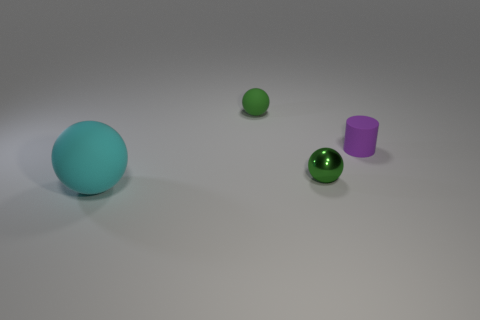Is the shape of the tiny green thing that is in front of the purple rubber object the same as the matte object that is in front of the purple rubber cylinder?
Your answer should be compact. Yes. How many small things are on the left side of the small purple cylinder and on the right side of the green rubber ball?
Make the answer very short. 1. What number of other things are there of the same size as the metal thing?
Give a very brief answer. 2. What material is the small thing that is behind the small metal thing and to the right of the tiny matte ball?
Your answer should be very brief. Rubber. There is a small matte sphere; is it the same color as the thing that is in front of the shiny sphere?
Give a very brief answer. No. What is the size of the cyan rubber object that is the same shape as the shiny thing?
Offer a very short reply. Large. The rubber thing that is in front of the green matte sphere and behind the cyan rubber sphere has what shape?
Your answer should be compact. Cylinder. Do the rubber cylinder and the matte sphere that is in front of the small purple matte cylinder have the same size?
Your response must be concise. No. What is the color of the other tiny object that is the same shape as the tiny metallic object?
Give a very brief answer. Green. Does the green rubber thing behind the small rubber cylinder have the same size as the rubber thing on the right side of the small shiny object?
Your answer should be very brief. Yes. 